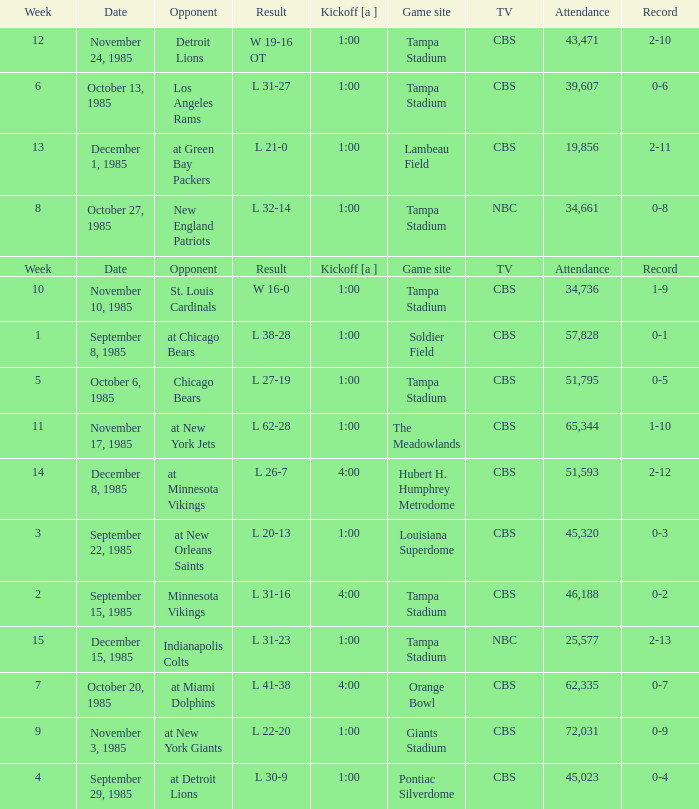Find all the result(s) with the record of 2-13. L 31-23. 